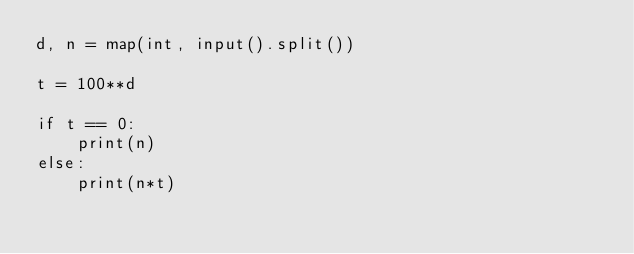<code> <loc_0><loc_0><loc_500><loc_500><_Python_>d, n = map(int, input().split())

t = 100**d

if t == 0:
    print(n)
else:
    print(n*t)
</code> 